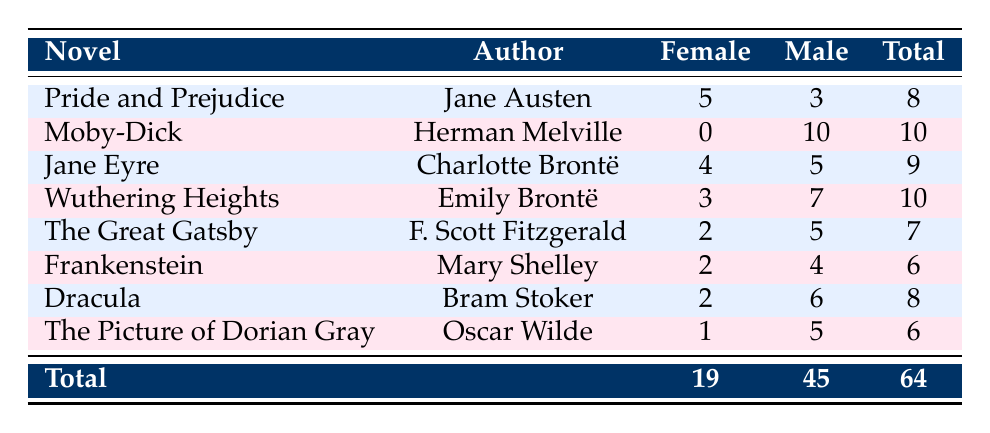What is the total number of female characters across all novels? To find the total number of female characters, add the female character counts from each novel: 5 + 0 + 4 + 3 + 2 + 2 + 2 + 1 = 19
Answer: 19 Which novel has the highest number of male characters? The male character counts from each novel are: 3, 10, 5, 7, 5, 4, 6, and 5. The highest count is 10 from Moby-Dick
Answer: Moby-Dick Is there any novel that features more female characters than male characters? By checking each novel's counts, only Pride and Prejudice has 5 female characters compared to 3 male characters. Therefore, yes, this statement is true
Answer: Yes What is the average number of male characters per novel? There are 8 novels and the total number of male characters is 45. The average is calculated as 45 divided by 8 which equals 5.625
Answer: 5.625 Which female character count is greater, for Jane Eyre or The Great Gatsby? Jane Eyre has 4 female characters while The Great Gatsby has 2. Since 4 is greater than 2, Jane Eyre has more female characters
Answer: Jane Eyre What is the total number of characters (both male and female) in Wuthering Heights? For Wuthering Heights, there are 3 female and 7 male characters, which adds up to 3 + 7 = 10 total characters
Answer: 10 Are there fewer than 5 female characters in The Picture of Dorian Gray? The Picture of Dorian Gray has 1 female character which is indeed fewer than 5, confirming the statement is true
Answer: Yes Which author has written a novel with no female characters? Moby-Dick by Herman Melville includes 0 female characters, making this the only novel without any female representation
Answer: Herman Melville 